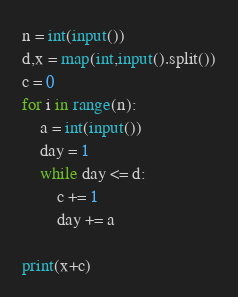Convert code to text. <code><loc_0><loc_0><loc_500><loc_500><_Python_>n = int(input())
d,x = map(int,input().split())
c = 0
for i in range(n):
    a = int(input())
    day = 1
    while day <= d:
        c += 1
        day += a

print(x+c)</code> 